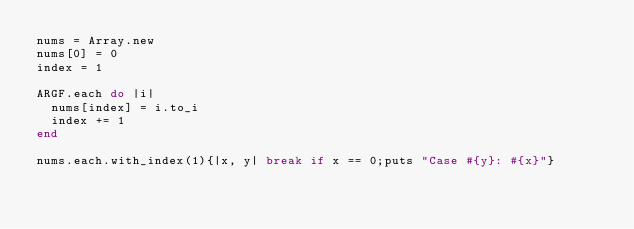Convert code to text. <code><loc_0><loc_0><loc_500><loc_500><_Ruby_>nums = Array.new
nums[0] = 0
index = 1

ARGF.each do |i|
  nums[index] = i.to_i
  index += 1
end

nums.each.with_index(1){|x, y| break if x == 0;puts "Case #{y}: #{x}"}</code> 